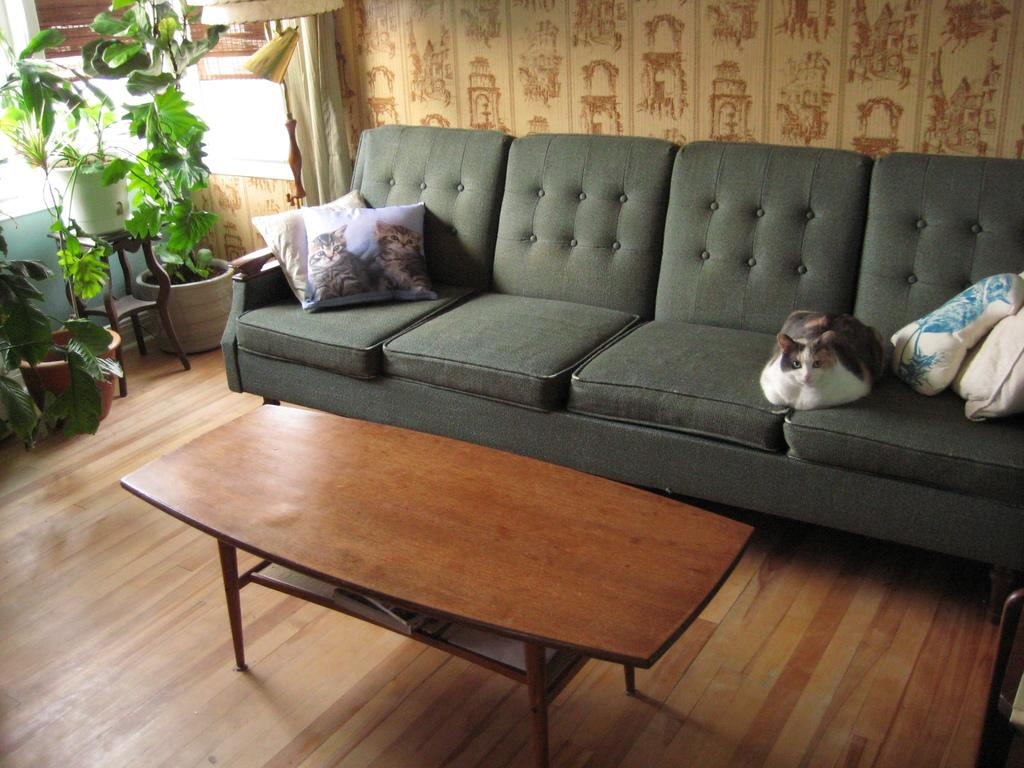What type of furniture is on the floor in the image? There is a sofa on the floor in the image. What is on the sofa? A cat is on the sofa. What is used for comfort on the sofa? There are pillows on the sofa. What can be seen in the background of the image? There is a wall in the background. What other piece of furniture is in the image? There is a table in the image. What type of decorative items are present in the image? Flower pots are present in the image. What type of grape is being used as a decoration on the sofa? There are no grapes present in the image, and therefore no grapes are being used as decoration on the sofa. What material is the cat's root made of in the image? There is no cat with a root in the image, and therefore no material can be identified for the cat's root. 